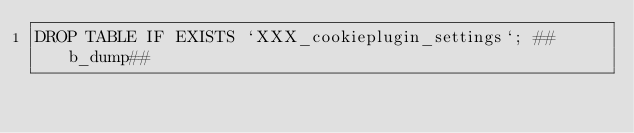<code> <loc_0><loc_0><loc_500><loc_500><_SQL_>DROP TABLE IF EXISTS `XXX_cookieplugin_settings`; ##b_dump##</code> 